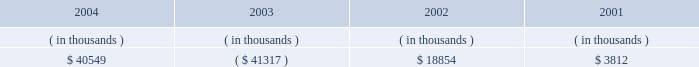Entergy louisiana , inc .
Management's financial discussion and analysis setting any of entergy louisiana's rates .
Therefore , to the extent entergy louisiana's use of the proceeds would ordinarily have reduced its rate base , no change in rate base shall be reflected for ratemaking purposes .
The sec approval for additional return of equity capital is now expired .
Entergy louisiana's receivables from or ( payables to ) the money pool were as follows as of december 31 for each of the following years: .
Money pool activity used $ 81.9 million of entergy louisiana's operating cash flow in 2004 , provided $ 60.2 million in 2003 , and used $ 15.0 million in 2002 .
See note 4 to the domestic utility companies and system energy financial statements for a description of the money pool .
Investing activities the decrease of $ 25.1 million in net cash used by investing activities in 2004 was primarily due to decreased spending on customer service projects , partially offset by increases in spending on transmission projects and fossil plant projects .
The increase of $ 56.0 million in net cash used by investing activities in 2003 was primarily due to increased spending on customer service , transmission , and nuclear projects .
Financing activities the decrease of $ 404.4 million in net cash used by financing activities in 2004 was primarily due to : 2022 the net issuance of $ 98.0 million of long-term debt in 2004 compared to the retirement of $ 261.0 million in 2022 a principal payment of $ 14.8 million in 2004 for the waterford lease obligation compared to a principal payment of $ 35.4 million in 2003 ; and 2022 a decrease of $ 29.0 million in common stock dividends paid .
The decrease of $ 105.5 million in net cash used by financing activities in 2003 was primarily due to : 2022 a decrease of $ 125.9 million in common stock dividends paid ; and 2022 the repurchase of $ 120 million of common stock from entergy corporation in 2002 .
The decrease in net cash used in 2003 was partially offset by the following : 2022 the retirement in 2003 of $ 150 million of 8.5% ( 8.5 % ) series first mortgage bonds compared to the net retirement of $ 134.6 million of first mortgage bonds in 2002 ; and 2022 principal payments of $ 35.4 million in 2003 for the waterford 3 lease obligation compared to principal payments of $ 15.9 million in 2002 .
See note 5 to the domestic utility companies and system energy financial statements for details of long-term debt .
Uses of capital entergy louisiana requires capital resources for : 2022 construction and other capital investments ; 2022 debt and preferred stock maturities ; 2022 working capital purposes , including the financing of fuel and purchased power costs ; and 2022 dividend and interest payments. .
What is the the net issuance of long-term debt as a percentage of the decrease in net cash used by financing activities in 2004? 
Computations: (98.0 / 404.4)
Answer: 0.24233. Entergy louisiana , inc .
Management's financial discussion and analysis setting any of entergy louisiana's rates .
Therefore , to the extent entergy louisiana's use of the proceeds would ordinarily have reduced its rate base , no change in rate base shall be reflected for ratemaking purposes .
The sec approval for additional return of equity capital is now expired .
Entergy louisiana's receivables from or ( payables to ) the money pool were as follows as of december 31 for each of the following years: .
Money pool activity used $ 81.9 million of entergy louisiana's operating cash flow in 2004 , provided $ 60.2 million in 2003 , and used $ 15.0 million in 2002 .
See note 4 to the domestic utility companies and system energy financial statements for a description of the money pool .
Investing activities the decrease of $ 25.1 million in net cash used by investing activities in 2004 was primarily due to decreased spending on customer service projects , partially offset by increases in spending on transmission projects and fossil plant projects .
The increase of $ 56.0 million in net cash used by investing activities in 2003 was primarily due to increased spending on customer service , transmission , and nuclear projects .
Financing activities the decrease of $ 404.4 million in net cash used by financing activities in 2004 was primarily due to : 2022 the net issuance of $ 98.0 million of long-term debt in 2004 compared to the retirement of $ 261.0 million in 2022 a principal payment of $ 14.8 million in 2004 for the waterford lease obligation compared to a principal payment of $ 35.4 million in 2003 ; and 2022 a decrease of $ 29.0 million in common stock dividends paid .
The decrease of $ 105.5 million in net cash used by financing activities in 2003 was primarily due to : 2022 a decrease of $ 125.9 million in common stock dividends paid ; and 2022 the repurchase of $ 120 million of common stock from entergy corporation in 2002 .
The decrease in net cash used in 2003 was partially offset by the following : 2022 the retirement in 2003 of $ 150 million of 8.5% ( 8.5 % ) series first mortgage bonds compared to the net retirement of $ 134.6 million of first mortgage bonds in 2002 ; and 2022 principal payments of $ 35.4 million in 2003 for the waterford 3 lease obligation compared to principal payments of $ 15.9 million in 2002 .
See note 5 to the domestic utility companies and system energy financial statements for details of long-term debt .
Uses of capital entergy louisiana requires capital resources for : 2022 construction and other capital investments ; 2022 debt and preferred stock maturities ; 2022 working capital purposes , including the financing of fuel and purchased power costs ; and 2022 dividend and interest payments. .
What is the difference of the payment for waterford lease obligation between 2003 and 2004? 
Computations: (35.4 - 14.8)
Answer: 20.6. 